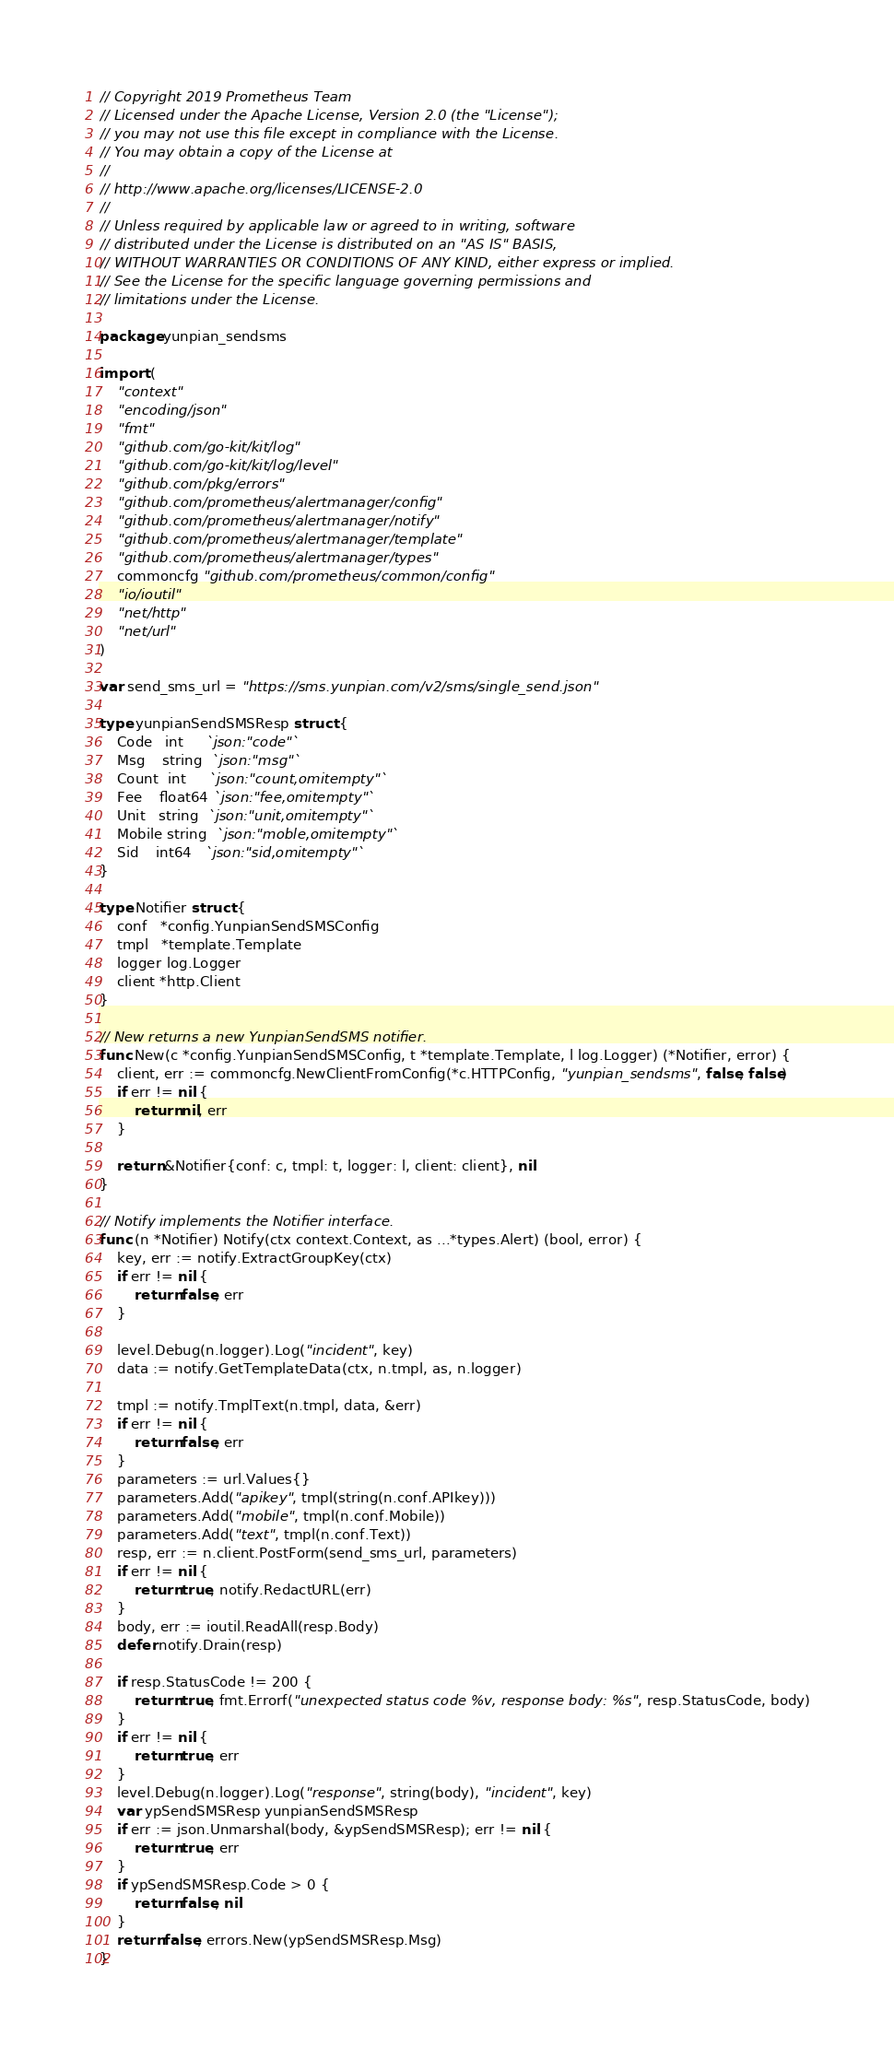Convert code to text. <code><loc_0><loc_0><loc_500><loc_500><_Go_>// Copyright 2019 Prometheus Team
// Licensed under the Apache License, Version 2.0 (the "License");
// you may not use this file except in compliance with the License.
// You may obtain a copy of the License at
//
// http://www.apache.org/licenses/LICENSE-2.0
//
// Unless required by applicable law or agreed to in writing, software
// distributed under the License is distributed on an "AS IS" BASIS,
// WITHOUT WARRANTIES OR CONDITIONS OF ANY KIND, either express or implied.
// See the License for the specific language governing permissions and
// limitations under the License.

package yunpian_sendsms

import (
	"context"
	"encoding/json"
	"fmt"
	"github.com/go-kit/kit/log"
	"github.com/go-kit/kit/log/level"
	"github.com/pkg/errors"
	"github.com/prometheus/alertmanager/config"
	"github.com/prometheus/alertmanager/notify"
	"github.com/prometheus/alertmanager/template"
	"github.com/prometheus/alertmanager/types"
	commoncfg "github.com/prometheus/common/config"
	"io/ioutil"
	"net/http"
	"net/url"
)

var send_sms_url = "https://sms.yunpian.com/v2/sms/single_send.json"

type yunpianSendSMSResp struct {
	Code   int     `json:"code"`
	Msg    string  `json:"msg"`
	Count  int     `json:"count,omitempty"`
	Fee    float64 `json:"fee,omitempty"`
	Unit   string  `json:"unit,omitempty"`
	Mobile string  `json:"moble,omitempty"`
	Sid    int64   `json:"sid,omitempty"`
}

type Notifier struct {
	conf   *config.YunpianSendSMSConfig
	tmpl   *template.Template
	logger log.Logger
	client *http.Client
}

// New returns a new YunpianSendSMS notifier.
func New(c *config.YunpianSendSMSConfig, t *template.Template, l log.Logger) (*Notifier, error) {
	client, err := commoncfg.NewClientFromConfig(*c.HTTPConfig, "yunpian_sendsms", false, false)
	if err != nil {
		return nil, err
	}

	return &Notifier{conf: c, tmpl: t, logger: l, client: client}, nil
}

// Notify implements the Notifier interface.
func (n *Notifier) Notify(ctx context.Context, as ...*types.Alert) (bool, error) {
	key, err := notify.ExtractGroupKey(ctx)
	if err != nil {
		return false, err
	}

	level.Debug(n.logger).Log("incident", key)
	data := notify.GetTemplateData(ctx, n.tmpl, as, n.logger)

	tmpl := notify.TmplText(n.tmpl, data, &err)
	if err != nil {
		return false, err
	}
	parameters := url.Values{}
	parameters.Add("apikey", tmpl(string(n.conf.APIkey)))
	parameters.Add("mobile", tmpl(n.conf.Mobile))
	parameters.Add("text", tmpl(n.conf.Text))
	resp, err := n.client.PostForm(send_sms_url, parameters)
	if err != nil {
		return true, notify.RedactURL(err)
	}
	body, err := ioutil.ReadAll(resp.Body)
	defer notify.Drain(resp)

	if resp.StatusCode != 200 {
		return true, fmt.Errorf("unexpected status code %v, response body: %s", resp.StatusCode, body)
	}
	if err != nil {
		return true, err
	}
	level.Debug(n.logger).Log("response", string(body), "incident", key)
	var ypSendSMSResp yunpianSendSMSResp
	if err := json.Unmarshal(body, &ypSendSMSResp); err != nil {
		return true, err
	}
	if ypSendSMSResp.Code > 0 {
		return false, nil
	}
	return false, errors.New(ypSendSMSResp.Msg)
}
</code> 